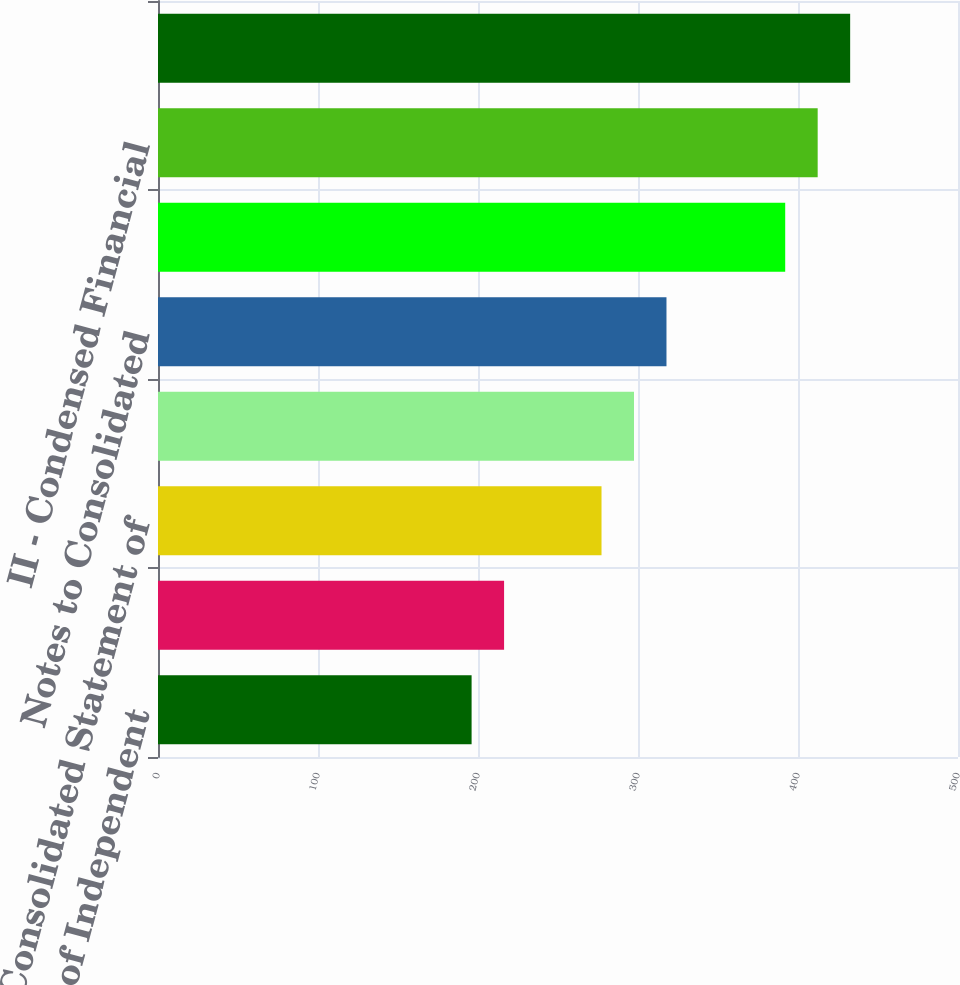Convert chart. <chart><loc_0><loc_0><loc_500><loc_500><bar_chart><fcel>Report of Independent<fcel>Consolidated Balance Sheet at<fcel>Consolidated Statement of<fcel>Consolidated Statement of Cash<fcel>Notes to Consolidated<fcel>I - Summary of Investments -<fcel>II - Condensed Financial<fcel>III - Supplementary Insurance<nl><fcel>196<fcel>216.3<fcel>277.2<fcel>297.5<fcel>317.8<fcel>392<fcel>412.3<fcel>432.6<nl></chart> 